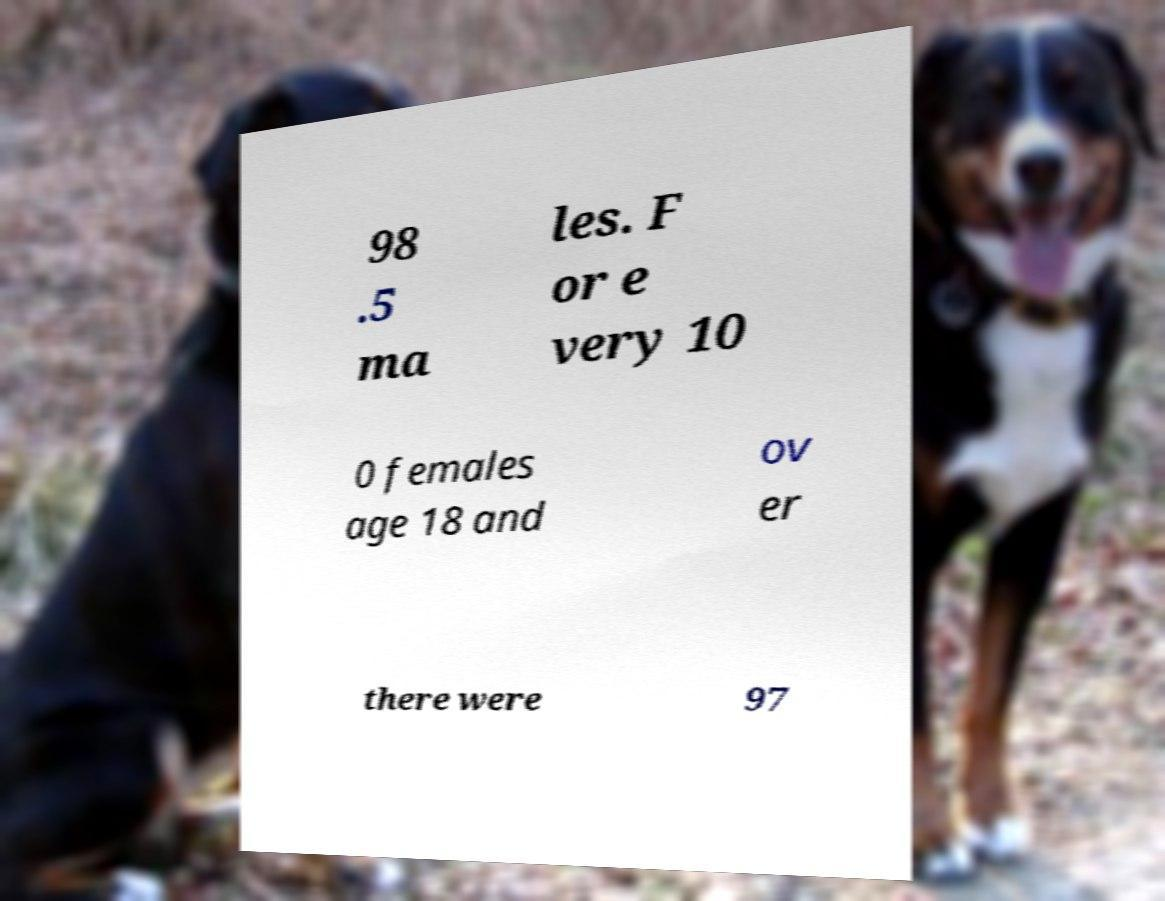There's text embedded in this image that I need extracted. Can you transcribe it verbatim? 98 .5 ma les. F or e very 10 0 females age 18 and ov er there were 97 